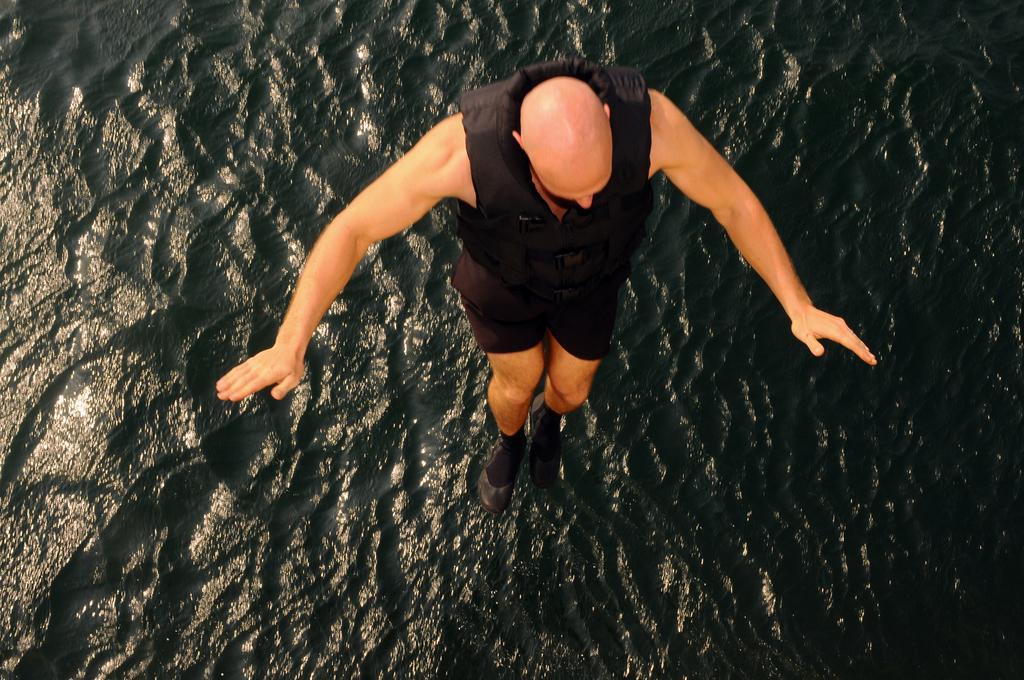How would you summarize this image in a sentence or two? In the center of the image we can see a man jumping into the sea. He is wearing a black jacket. At the bottom there is a sea. 